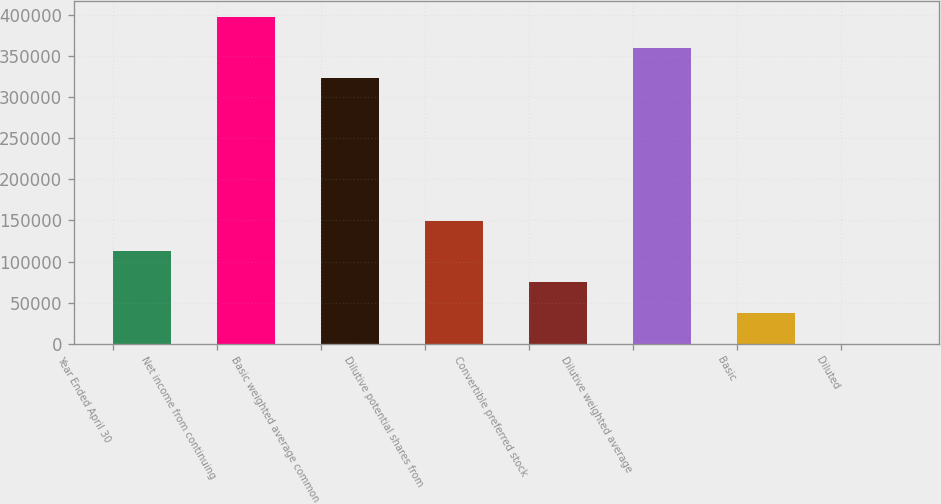Convert chart to OTSL. <chart><loc_0><loc_0><loc_500><loc_500><bar_chart><fcel>Year Ended April 30<fcel>Net income from continuing<fcel>Basic weighted average common<fcel>Dilutive potential shares from<fcel>Convertible preferred stock<fcel>Dilutive weighted average<fcel>Basic<fcel>Diluted<nl><fcel>112302<fcel>397555<fcel>322688<fcel>149735<fcel>74868.3<fcel>360122<fcel>37434.7<fcel>1.15<nl></chart> 